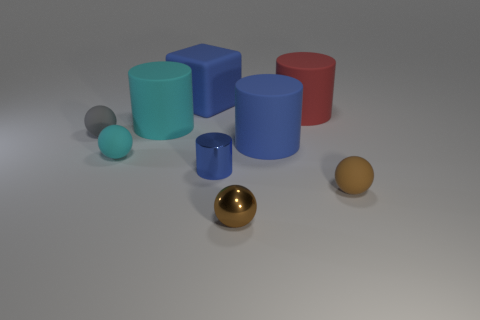Add 1 yellow rubber things. How many objects exist? 10 Subtract all spheres. How many objects are left? 5 Add 2 shiny balls. How many shiny balls exist? 3 Subtract 0 purple cylinders. How many objects are left? 9 Subtract all cyan matte cylinders. Subtract all cyan matte spheres. How many objects are left? 7 Add 3 small gray matte things. How many small gray matte things are left? 4 